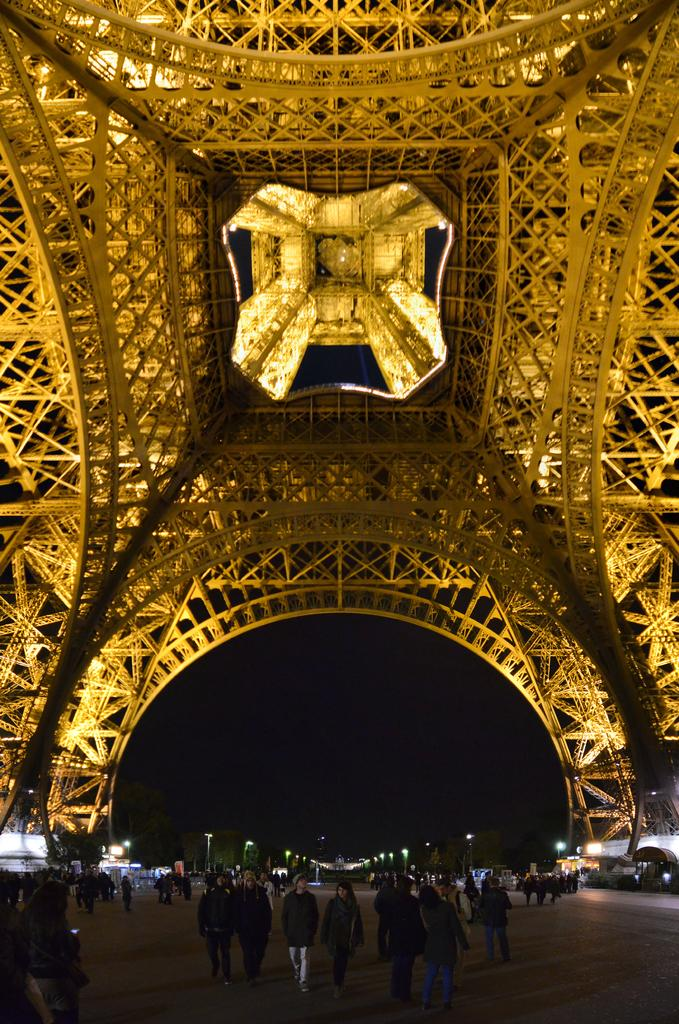What famous landmark can be seen in the image? The Eiffel tower is visible in the image. What are the people at the bottom of the image doing? There are people walking at the bottom of the image. What can be seen illuminated in the image? Lights are present in the image. What type of natural scenery is visible in the background of the image? Trees are visible in the background of the image. What type of wood can be seen in the image? There is no wood present in the image. How does the jelly interact with the people walking in the image? There is no jelly present in the image; the people are walking near the Eiffel tower. 